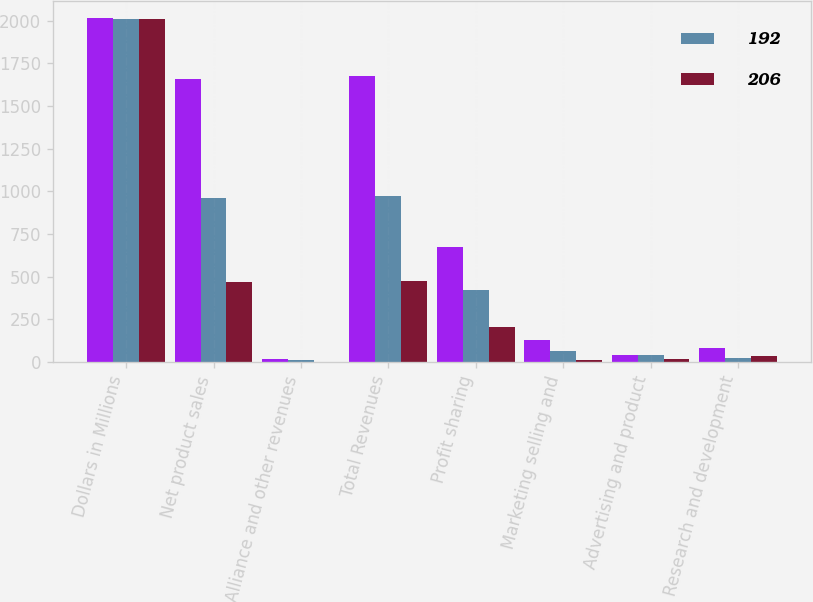<chart> <loc_0><loc_0><loc_500><loc_500><stacked_bar_chart><ecel><fcel>Dollars in Millions<fcel>Net product sales<fcel>Alliance and other revenues<fcel>Total Revenues<fcel>Profit sharing<fcel>Marketing selling and<fcel>Advertising and product<fcel>Research and development<nl><fcel>nan<fcel>2013<fcel>1658<fcel>16<fcel>1674<fcel>673<fcel>127<fcel>45<fcel>86<nl><fcel>192<fcel>2012<fcel>962<fcel>10<fcel>972<fcel>425<fcel>66<fcel>43<fcel>25<nl><fcel>206<fcel>2011<fcel>472<fcel>1<fcel>473<fcel>207<fcel>14<fcel>21<fcel>35<nl></chart> 